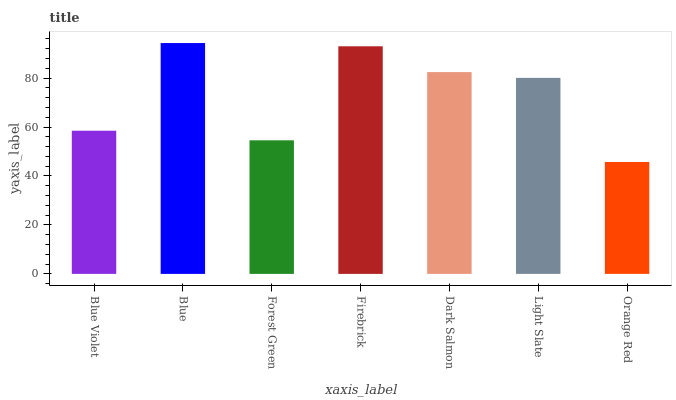Is Forest Green the minimum?
Answer yes or no. No. Is Forest Green the maximum?
Answer yes or no. No. Is Blue greater than Forest Green?
Answer yes or no. Yes. Is Forest Green less than Blue?
Answer yes or no. Yes. Is Forest Green greater than Blue?
Answer yes or no. No. Is Blue less than Forest Green?
Answer yes or no. No. Is Light Slate the high median?
Answer yes or no. Yes. Is Light Slate the low median?
Answer yes or no. Yes. Is Blue Violet the high median?
Answer yes or no. No. Is Forest Green the low median?
Answer yes or no. No. 